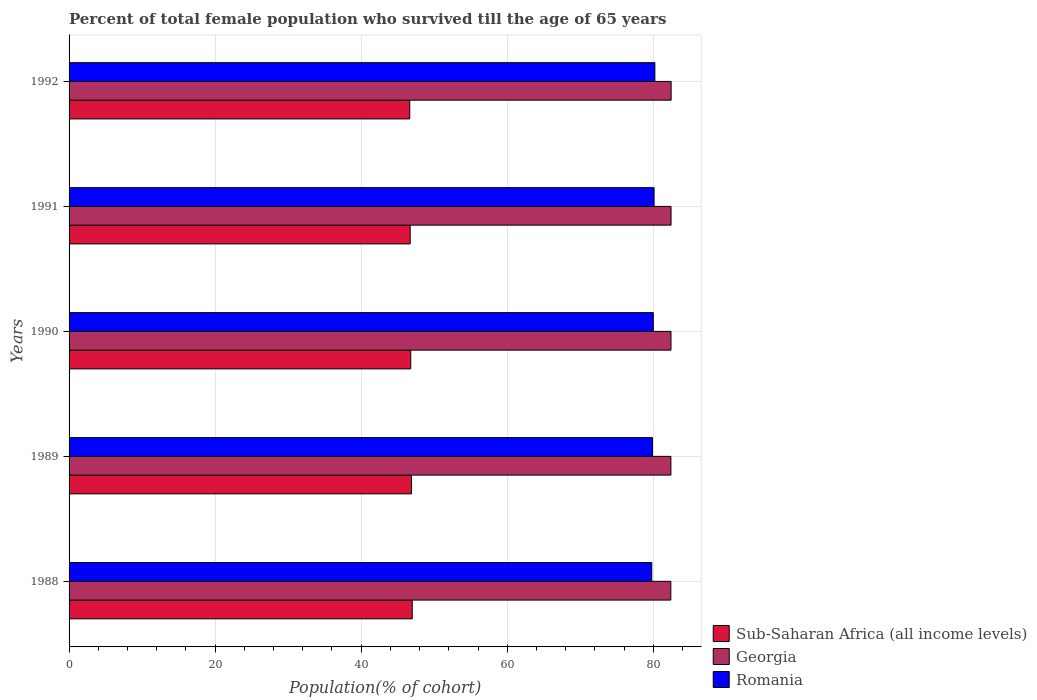How many different coloured bars are there?
Provide a short and direct response. 3. How many groups of bars are there?
Make the answer very short. 5. What is the percentage of total female population who survived till the age of 65 years in Sub-Saharan Africa (all income levels) in 1989?
Your response must be concise. 46.89. Across all years, what is the maximum percentage of total female population who survived till the age of 65 years in Georgia?
Keep it short and to the point. 82.44. Across all years, what is the minimum percentage of total female population who survived till the age of 65 years in Romania?
Provide a succinct answer. 79.78. What is the total percentage of total female population who survived till the age of 65 years in Romania in the graph?
Provide a succinct answer. 399.98. What is the difference between the percentage of total female population who survived till the age of 65 years in Sub-Saharan Africa (all income levels) in 1988 and that in 1992?
Offer a very short reply. 0.34. What is the difference between the percentage of total female population who survived till the age of 65 years in Romania in 1992 and the percentage of total female population who survived till the age of 65 years in Georgia in 1991?
Ensure brevity in your answer.  -2.22. What is the average percentage of total female population who survived till the age of 65 years in Georgia per year?
Provide a succinct answer. 82.42. In the year 1991, what is the difference between the percentage of total female population who survived till the age of 65 years in Sub-Saharan Africa (all income levels) and percentage of total female population who survived till the age of 65 years in Romania?
Ensure brevity in your answer.  -33.39. What is the ratio of the percentage of total female population who survived till the age of 65 years in Georgia in 1989 to that in 1992?
Provide a succinct answer. 1. Is the percentage of total female population who survived till the age of 65 years in Romania in 1988 less than that in 1989?
Give a very brief answer. Yes. What is the difference between the highest and the second highest percentage of total female population who survived till the age of 65 years in Georgia?
Provide a succinct answer. 0.01. What is the difference between the highest and the lowest percentage of total female population who survived till the age of 65 years in Georgia?
Your answer should be very brief. 0.04. What does the 2nd bar from the top in 1988 represents?
Keep it short and to the point. Georgia. What does the 1st bar from the bottom in 1992 represents?
Your answer should be very brief. Sub-Saharan Africa (all income levels). How many bars are there?
Provide a short and direct response. 15. What is the difference between two consecutive major ticks on the X-axis?
Your response must be concise. 20. Does the graph contain any zero values?
Offer a terse response. No. Does the graph contain grids?
Ensure brevity in your answer.  Yes. Where does the legend appear in the graph?
Offer a very short reply. Bottom right. How are the legend labels stacked?
Your answer should be very brief. Vertical. What is the title of the graph?
Keep it short and to the point. Percent of total female population who survived till the age of 65 years. Does "Thailand" appear as one of the legend labels in the graph?
Provide a short and direct response. No. What is the label or title of the X-axis?
Ensure brevity in your answer.  Population(% of cohort). What is the Population(% of cohort) in Sub-Saharan Africa (all income levels) in 1988?
Make the answer very short. 46.99. What is the Population(% of cohort) in Georgia in 1988?
Provide a short and direct response. 82.4. What is the Population(% of cohort) of Romania in 1988?
Your response must be concise. 79.78. What is the Population(% of cohort) of Sub-Saharan Africa (all income levels) in 1989?
Ensure brevity in your answer.  46.89. What is the Population(% of cohort) of Georgia in 1989?
Give a very brief answer. 82.41. What is the Population(% of cohort) of Romania in 1989?
Make the answer very short. 79.89. What is the Population(% of cohort) of Sub-Saharan Africa (all income levels) in 1990?
Your answer should be compact. 46.78. What is the Population(% of cohort) in Georgia in 1990?
Provide a short and direct response. 82.42. What is the Population(% of cohort) in Romania in 1990?
Make the answer very short. 80. What is the Population(% of cohort) of Sub-Saharan Africa (all income levels) in 1991?
Offer a terse response. 46.71. What is the Population(% of cohort) in Georgia in 1991?
Make the answer very short. 82.43. What is the Population(% of cohort) of Romania in 1991?
Keep it short and to the point. 80.1. What is the Population(% of cohort) in Sub-Saharan Africa (all income levels) in 1992?
Your answer should be very brief. 46.65. What is the Population(% of cohort) in Georgia in 1992?
Keep it short and to the point. 82.44. What is the Population(% of cohort) of Romania in 1992?
Offer a terse response. 80.21. Across all years, what is the maximum Population(% of cohort) in Sub-Saharan Africa (all income levels)?
Offer a terse response. 46.99. Across all years, what is the maximum Population(% of cohort) of Georgia?
Make the answer very short. 82.44. Across all years, what is the maximum Population(% of cohort) in Romania?
Offer a very short reply. 80.21. Across all years, what is the minimum Population(% of cohort) of Sub-Saharan Africa (all income levels)?
Your answer should be compact. 46.65. Across all years, what is the minimum Population(% of cohort) in Georgia?
Give a very brief answer. 82.4. Across all years, what is the minimum Population(% of cohort) of Romania?
Offer a terse response. 79.78. What is the total Population(% of cohort) in Sub-Saharan Africa (all income levels) in the graph?
Offer a terse response. 234.01. What is the total Population(% of cohort) of Georgia in the graph?
Your answer should be very brief. 412.08. What is the total Population(% of cohort) in Romania in the graph?
Your answer should be compact. 399.98. What is the difference between the Population(% of cohort) of Sub-Saharan Africa (all income levels) in 1988 and that in 1989?
Provide a short and direct response. 0.1. What is the difference between the Population(% of cohort) in Georgia in 1988 and that in 1989?
Your response must be concise. -0.01. What is the difference between the Population(% of cohort) in Romania in 1988 and that in 1989?
Give a very brief answer. -0.11. What is the difference between the Population(% of cohort) of Sub-Saharan Africa (all income levels) in 1988 and that in 1990?
Keep it short and to the point. 0.2. What is the difference between the Population(% of cohort) in Georgia in 1988 and that in 1990?
Keep it short and to the point. -0.02. What is the difference between the Population(% of cohort) in Romania in 1988 and that in 1990?
Give a very brief answer. -0.21. What is the difference between the Population(% of cohort) in Sub-Saharan Africa (all income levels) in 1988 and that in 1991?
Your answer should be very brief. 0.28. What is the difference between the Population(% of cohort) of Georgia in 1988 and that in 1991?
Your answer should be compact. -0.03. What is the difference between the Population(% of cohort) of Romania in 1988 and that in 1991?
Offer a very short reply. -0.32. What is the difference between the Population(% of cohort) in Sub-Saharan Africa (all income levels) in 1988 and that in 1992?
Offer a very short reply. 0.34. What is the difference between the Population(% of cohort) in Georgia in 1988 and that in 1992?
Ensure brevity in your answer.  -0.04. What is the difference between the Population(% of cohort) in Romania in 1988 and that in 1992?
Provide a short and direct response. -0.43. What is the difference between the Population(% of cohort) in Sub-Saharan Africa (all income levels) in 1989 and that in 1990?
Your answer should be very brief. 0.1. What is the difference between the Population(% of cohort) in Georgia in 1989 and that in 1990?
Offer a terse response. -0.01. What is the difference between the Population(% of cohort) of Romania in 1989 and that in 1990?
Offer a terse response. -0.11. What is the difference between the Population(% of cohort) of Sub-Saharan Africa (all income levels) in 1989 and that in 1991?
Offer a terse response. 0.18. What is the difference between the Population(% of cohort) in Georgia in 1989 and that in 1991?
Give a very brief answer. -0.02. What is the difference between the Population(% of cohort) of Romania in 1989 and that in 1991?
Your answer should be compact. -0.21. What is the difference between the Population(% of cohort) of Sub-Saharan Africa (all income levels) in 1989 and that in 1992?
Provide a succinct answer. 0.24. What is the difference between the Population(% of cohort) in Georgia in 1989 and that in 1992?
Offer a terse response. -0.03. What is the difference between the Population(% of cohort) in Romania in 1989 and that in 1992?
Your response must be concise. -0.32. What is the difference between the Population(% of cohort) of Sub-Saharan Africa (all income levels) in 1990 and that in 1991?
Your answer should be very brief. 0.08. What is the difference between the Population(% of cohort) of Georgia in 1990 and that in 1991?
Your response must be concise. -0.01. What is the difference between the Population(% of cohort) of Romania in 1990 and that in 1991?
Keep it short and to the point. -0.11. What is the difference between the Population(% of cohort) of Sub-Saharan Africa (all income levels) in 1990 and that in 1992?
Make the answer very short. 0.14. What is the difference between the Population(% of cohort) of Georgia in 1990 and that in 1992?
Provide a short and direct response. -0.02. What is the difference between the Population(% of cohort) of Romania in 1990 and that in 1992?
Your response must be concise. -0.21. What is the difference between the Population(% of cohort) of Sub-Saharan Africa (all income levels) in 1991 and that in 1992?
Provide a short and direct response. 0.06. What is the difference between the Population(% of cohort) of Georgia in 1991 and that in 1992?
Ensure brevity in your answer.  -0.01. What is the difference between the Population(% of cohort) of Romania in 1991 and that in 1992?
Offer a terse response. -0.11. What is the difference between the Population(% of cohort) of Sub-Saharan Africa (all income levels) in 1988 and the Population(% of cohort) of Georgia in 1989?
Keep it short and to the point. -35.42. What is the difference between the Population(% of cohort) of Sub-Saharan Africa (all income levels) in 1988 and the Population(% of cohort) of Romania in 1989?
Give a very brief answer. -32.9. What is the difference between the Population(% of cohort) of Georgia in 1988 and the Population(% of cohort) of Romania in 1989?
Your response must be concise. 2.51. What is the difference between the Population(% of cohort) of Sub-Saharan Africa (all income levels) in 1988 and the Population(% of cohort) of Georgia in 1990?
Give a very brief answer. -35.43. What is the difference between the Population(% of cohort) of Sub-Saharan Africa (all income levels) in 1988 and the Population(% of cohort) of Romania in 1990?
Keep it short and to the point. -33.01. What is the difference between the Population(% of cohort) of Georgia in 1988 and the Population(% of cohort) of Romania in 1990?
Your response must be concise. 2.4. What is the difference between the Population(% of cohort) in Sub-Saharan Africa (all income levels) in 1988 and the Population(% of cohort) in Georgia in 1991?
Keep it short and to the point. -35.44. What is the difference between the Population(% of cohort) of Sub-Saharan Africa (all income levels) in 1988 and the Population(% of cohort) of Romania in 1991?
Give a very brief answer. -33.11. What is the difference between the Population(% of cohort) in Georgia in 1988 and the Population(% of cohort) in Romania in 1991?
Make the answer very short. 2.29. What is the difference between the Population(% of cohort) in Sub-Saharan Africa (all income levels) in 1988 and the Population(% of cohort) in Georgia in 1992?
Your answer should be compact. -35.45. What is the difference between the Population(% of cohort) of Sub-Saharan Africa (all income levels) in 1988 and the Population(% of cohort) of Romania in 1992?
Give a very brief answer. -33.22. What is the difference between the Population(% of cohort) in Georgia in 1988 and the Population(% of cohort) in Romania in 1992?
Provide a short and direct response. 2.19. What is the difference between the Population(% of cohort) in Sub-Saharan Africa (all income levels) in 1989 and the Population(% of cohort) in Georgia in 1990?
Offer a terse response. -35.53. What is the difference between the Population(% of cohort) in Sub-Saharan Africa (all income levels) in 1989 and the Population(% of cohort) in Romania in 1990?
Your answer should be compact. -33.11. What is the difference between the Population(% of cohort) of Georgia in 1989 and the Population(% of cohort) of Romania in 1990?
Your answer should be compact. 2.41. What is the difference between the Population(% of cohort) of Sub-Saharan Africa (all income levels) in 1989 and the Population(% of cohort) of Georgia in 1991?
Your answer should be compact. -35.54. What is the difference between the Population(% of cohort) of Sub-Saharan Africa (all income levels) in 1989 and the Population(% of cohort) of Romania in 1991?
Provide a short and direct response. -33.21. What is the difference between the Population(% of cohort) in Georgia in 1989 and the Population(% of cohort) in Romania in 1991?
Your answer should be compact. 2.3. What is the difference between the Population(% of cohort) in Sub-Saharan Africa (all income levels) in 1989 and the Population(% of cohort) in Georgia in 1992?
Your answer should be very brief. -35.55. What is the difference between the Population(% of cohort) of Sub-Saharan Africa (all income levels) in 1989 and the Population(% of cohort) of Romania in 1992?
Offer a terse response. -33.32. What is the difference between the Population(% of cohort) in Georgia in 1989 and the Population(% of cohort) in Romania in 1992?
Provide a succinct answer. 2.2. What is the difference between the Population(% of cohort) in Sub-Saharan Africa (all income levels) in 1990 and the Population(% of cohort) in Georgia in 1991?
Ensure brevity in your answer.  -35.64. What is the difference between the Population(% of cohort) in Sub-Saharan Africa (all income levels) in 1990 and the Population(% of cohort) in Romania in 1991?
Make the answer very short. -33.32. What is the difference between the Population(% of cohort) of Georgia in 1990 and the Population(% of cohort) of Romania in 1991?
Provide a succinct answer. 2.31. What is the difference between the Population(% of cohort) in Sub-Saharan Africa (all income levels) in 1990 and the Population(% of cohort) in Georgia in 1992?
Offer a terse response. -35.65. What is the difference between the Population(% of cohort) of Sub-Saharan Africa (all income levels) in 1990 and the Population(% of cohort) of Romania in 1992?
Make the answer very short. -33.42. What is the difference between the Population(% of cohort) of Georgia in 1990 and the Population(% of cohort) of Romania in 1992?
Offer a terse response. 2.21. What is the difference between the Population(% of cohort) of Sub-Saharan Africa (all income levels) in 1991 and the Population(% of cohort) of Georgia in 1992?
Keep it short and to the point. -35.73. What is the difference between the Population(% of cohort) of Sub-Saharan Africa (all income levels) in 1991 and the Population(% of cohort) of Romania in 1992?
Provide a succinct answer. -33.5. What is the difference between the Population(% of cohort) in Georgia in 1991 and the Population(% of cohort) in Romania in 1992?
Offer a very short reply. 2.22. What is the average Population(% of cohort) in Sub-Saharan Africa (all income levels) per year?
Your answer should be very brief. 46.8. What is the average Population(% of cohort) of Georgia per year?
Keep it short and to the point. 82.42. What is the average Population(% of cohort) in Romania per year?
Offer a terse response. 80. In the year 1988, what is the difference between the Population(% of cohort) of Sub-Saharan Africa (all income levels) and Population(% of cohort) of Georgia?
Offer a terse response. -35.41. In the year 1988, what is the difference between the Population(% of cohort) in Sub-Saharan Africa (all income levels) and Population(% of cohort) in Romania?
Keep it short and to the point. -32.79. In the year 1988, what is the difference between the Population(% of cohort) of Georgia and Population(% of cohort) of Romania?
Give a very brief answer. 2.61. In the year 1989, what is the difference between the Population(% of cohort) in Sub-Saharan Africa (all income levels) and Population(% of cohort) in Georgia?
Offer a terse response. -35.52. In the year 1989, what is the difference between the Population(% of cohort) in Sub-Saharan Africa (all income levels) and Population(% of cohort) in Romania?
Provide a succinct answer. -33. In the year 1989, what is the difference between the Population(% of cohort) of Georgia and Population(% of cohort) of Romania?
Your answer should be very brief. 2.52. In the year 1990, what is the difference between the Population(% of cohort) in Sub-Saharan Africa (all income levels) and Population(% of cohort) in Georgia?
Offer a very short reply. -35.63. In the year 1990, what is the difference between the Population(% of cohort) of Sub-Saharan Africa (all income levels) and Population(% of cohort) of Romania?
Your response must be concise. -33.21. In the year 1990, what is the difference between the Population(% of cohort) in Georgia and Population(% of cohort) in Romania?
Keep it short and to the point. 2.42. In the year 1991, what is the difference between the Population(% of cohort) of Sub-Saharan Africa (all income levels) and Population(% of cohort) of Georgia?
Provide a succinct answer. -35.72. In the year 1991, what is the difference between the Population(% of cohort) in Sub-Saharan Africa (all income levels) and Population(% of cohort) in Romania?
Offer a very short reply. -33.39. In the year 1991, what is the difference between the Population(% of cohort) of Georgia and Population(% of cohort) of Romania?
Your answer should be compact. 2.32. In the year 1992, what is the difference between the Population(% of cohort) in Sub-Saharan Africa (all income levels) and Population(% of cohort) in Georgia?
Your answer should be very brief. -35.79. In the year 1992, what is the difference between the Population(% of cohort) in Sub-Saharan Africa (all income levels) and Population(% of cohort) in Romania?
Make the answer very short. -33.56. In the year 1992, what is the difference between the Population(% of cohort) in Georgia and Population(% of cohort) in Romania?
Ensure brevity in your answer.  2.23. What is the ratio of the Population(% of cohort) in Sub-Saharan Africa (all income levels) in 1988 to that in 1989?
Provide a succinct answer. 1. What is the ratio of the Population(% of cohort) in Romania in 1988 to that in 1989?
Give a very brief answer. 1. What is the ratio of the Population(% of cohort) in Sub-Saharan Africa (all income levels) in 1988 to that in 1990?
Your response must be concise. 1. What is the ratio of the Population(% of cohort) in Georgia in 1988 to that in 1990?
Make the answer very short. 1. What is the ratio of the Population(% of cohort) of Sub-Saharan Africa (all income levels) in 1988 to that in 1991?
Provide a short and direct response. 1.01. What is the ratio of the Population(% of cohort) in Georgia in 1988 to that in 1991?
Your answer should be very brief. 1. What is the ratio of the Population(% of cohort) of Romania in 1988 to that in 1991?
Offer a very short reply. 1. What is the ratio of the Population(% of cohort) of Sub-Saharan Africa (all income levels) in 1988 to that in 1992?
Provide a short and direct response. 1.01. What is the ratio of the Population(% of cohort) in Romania in 1988 to that in 1992?
Make the answer very short. 0.99. What is the ratio of the Population(% of cohort) in Sub-Saharan Africa (all income levels) in 1989 to that in 1990?
Offer a terse response. 1. What is the ratio of the Population(% of cohort) of Georgia in 1989 to that in 1990?
Your response must be concise. 1. What is the ratio of the Population(% of cohort) in Sub-Saharan Africa (all income levels) in 1989 to that in 1991?
Your answer should be very brief. 1. What is the ratio of the Population(% of cohort) of Georgia in 1989 to that in 1991?
Offer a terse response. 1. What is the ratio of the Population(% of cohort) in Sub-Saharan Africa (all income levels) in 1989 to that in 1992?
Your answer should be very brief. 1.01. What is the ratio of the Population(% of cohort) in Romania in 1989 to that in 1992?
Keep it short and to the point. 1. What is the ratio of the Population(% of cohort) of Sub-Saharan Africa (all income levels) in 1990 to that in 1991?
Make the answer very short. 1. What is the ratio of the Population(% of cohort) of Georgia in 1990 to that in 1991?
Offer a very short reply. 1. What is the ratio of the Population(% of cohort) of Romania in 1990 to that in 1991?
Your answer should be very brief. 1. What is the ratio of the Population(% of cohort) of Romania in 1991 to that in 1992?
Provide a short and direct response. 1. What is the difference between the highest and the second highest Population(% of cohort) in Sub-Saharan Africa (all income levels)?
Provide a short and direct response. 0.1. What is the difference between the highest and the second highest Population(% of cohort) of Romania?
Your answer should be compact. 0.11. What is the difference between the highest and the lowest Population(% of cohort) in Sub-Saharan Africa (all income levels)?
Make the answer very short. 0.34. What is the difference between the highest and the lowest Population(% of cohort) of Romania?
Ensure brevity in your answer.  0.43. 